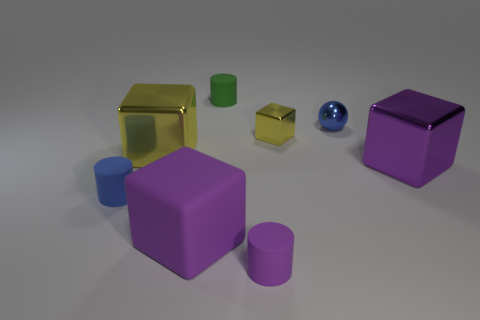There is a object that is the same color as the small metallic sphere; what is its shape?
Make the answer very short. Cylinder. What size is the cylinder that is in front of the thing left of the large yellow cube?
Your answer should be compact. Small. Do the yellow metallic thing in front of the tiny metal block and the small rubber object behind the large purple metal thing have the same shape?
Offer a terse response. No. Are there the same number of blue shiny spheres that are to the left of the small green rubber object and big purple metal objects?
Offer a very short reply. No. What color is the tiny shiny thing that is the same shape as the big purple matte object?
Ensure brevity in your answer.  Yellow. Do the cylinder that is in front of the blue cylinder and the tiny yellow cube have the same material?
Make the answer very short. No. How many tiny things are spheres or gray metallic balls?
Keep it short and to the point. 1. How big is the rubber cube?
Your answer should be compact. Large. There is a purple metal cube; is it the same size as the metallic block to the left of the small green matte object?
Offer a terse response. Yes. How many green things are either tiny metallic objects or tiny objects?
Give a very brief answer. 1. 